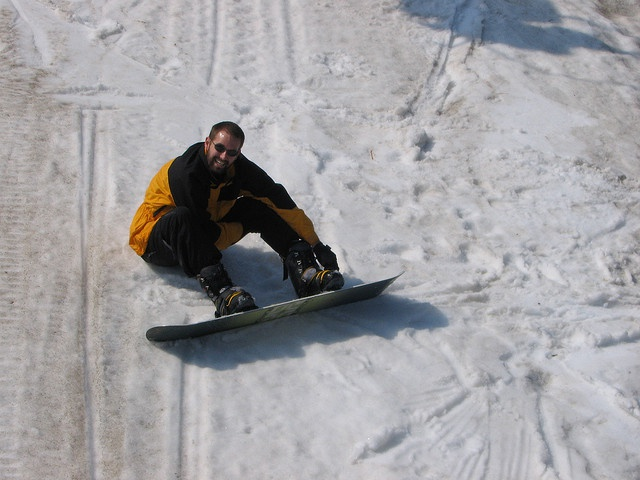Describe the objects in this image and their specific colors. I can see people in lightgray, black, maroon, red, and orange tones and snowboard in lightgray, black, gray, darkgray, and darkgreen tones in this image. 